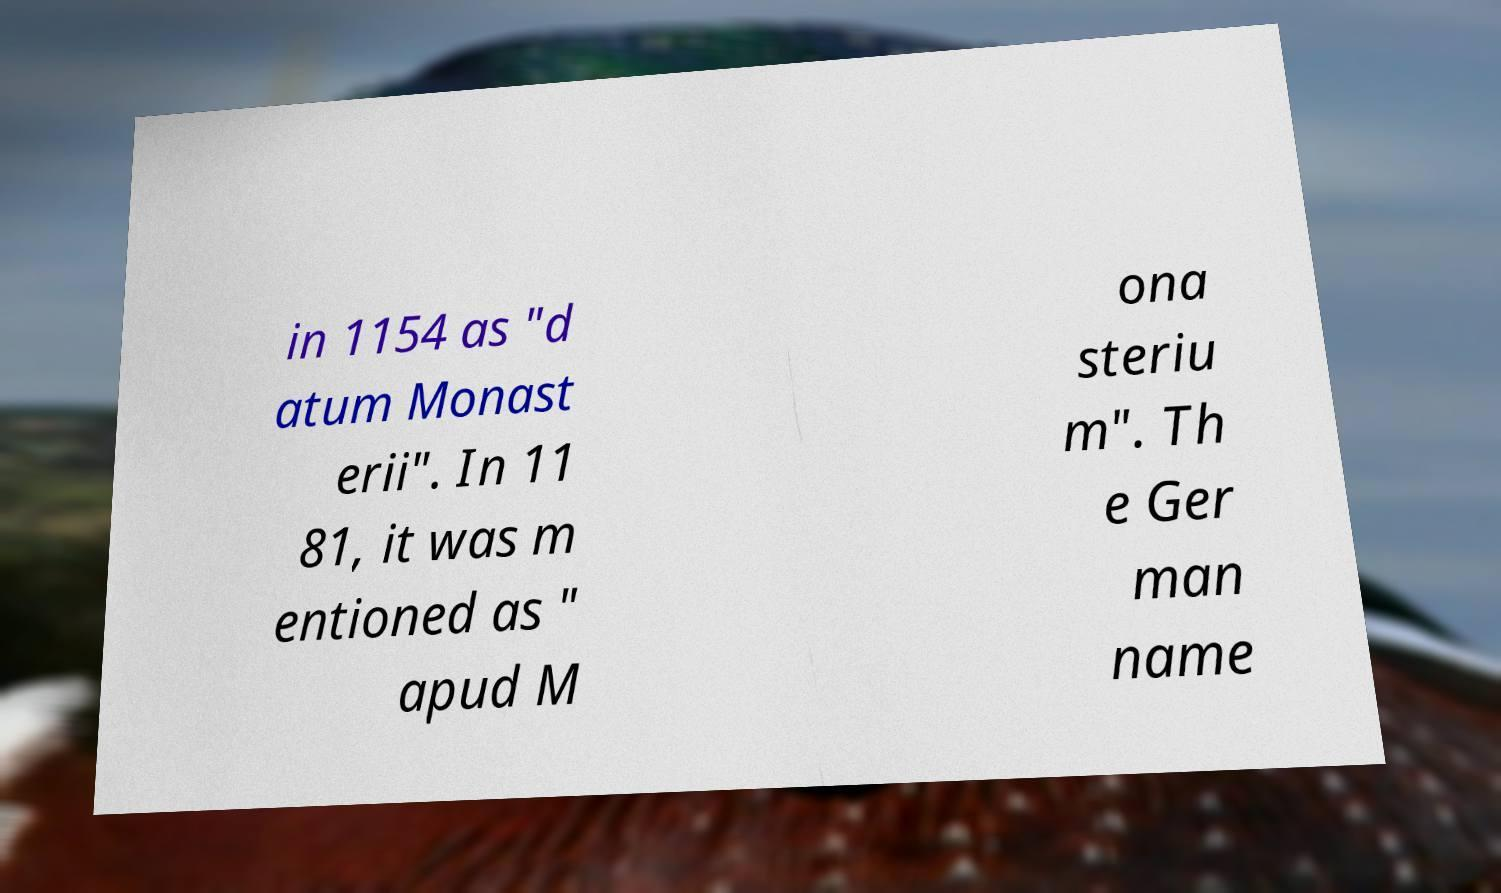Could you assist in decoding the text presented in this image and type it out clearly? in 1154 as "d atum Monast erii". In 11 81, it was m entioned as " apud M ona steriu m". Th e Ger man name 